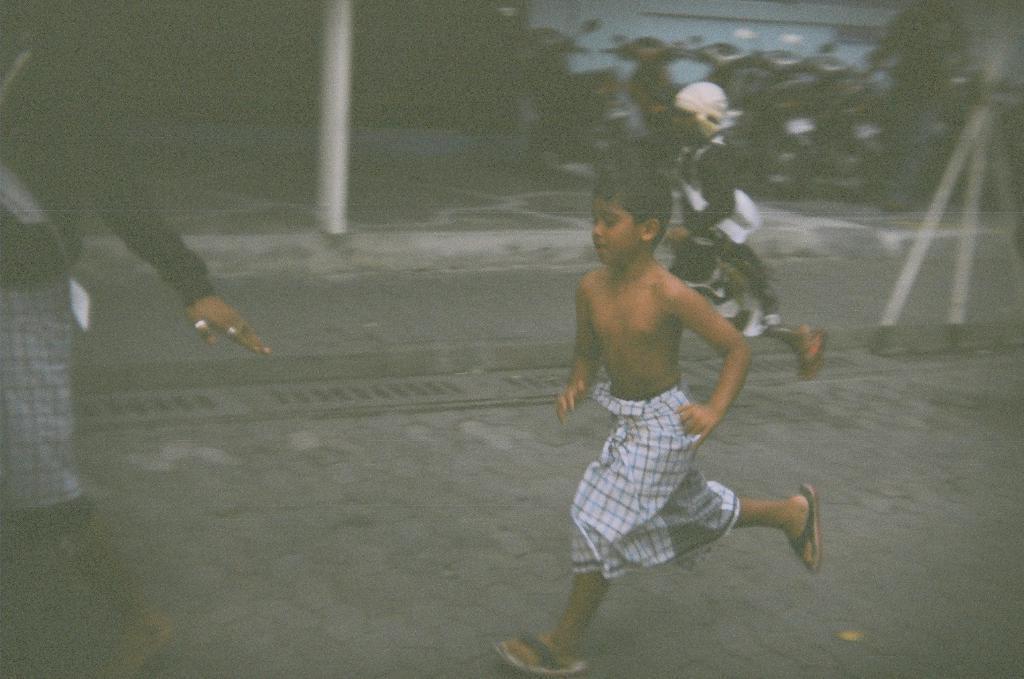How would you summarize this image in a sentence or two? In this image, we can see kids running on the road. There is a person on the left side of the image wearing clothes. There are some scooters in the top right of the image. There is a pole at the top of the image. 